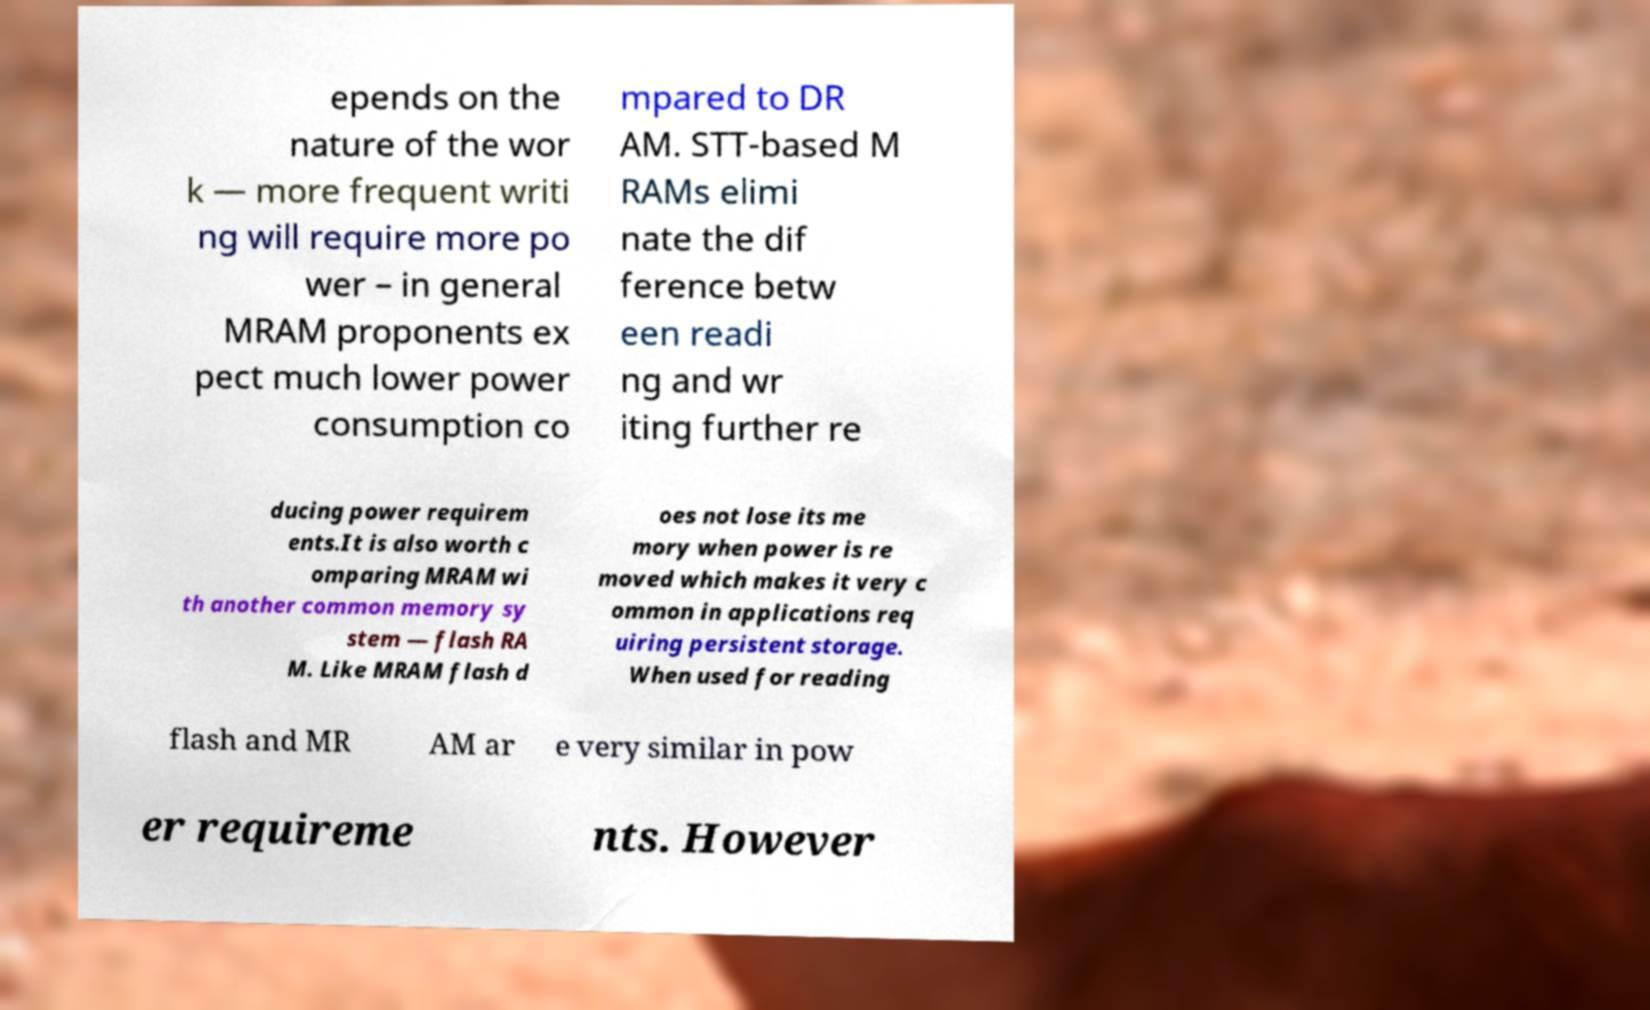Can you accurately transcribe the text from the provided image for me? epends on the nature of the wor k — more frequent writi ng will require more po wer – in general MRAM proponents ex pect much lower power consumption co mpared to DR AM. STT-based M RAMs elimi nate the dif ference betw een readi ng and wr iting further re ducing power requirem ents.It is also worth c omparing MRAM wi th another common memory sy stem — flash RA M. Like MRAM flash d oes not lose its me mory when power is re moved which makes it very c ommon in applications req uiring persistent storage. When used for reading flash and MR AM ar e very similar in pow er requireme nts. However 